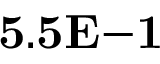Convert formula to latex. <formula><loc_0><loc_0><loc_500><loc_500>{ 5 . 5 E { - 1 } }</formula> 